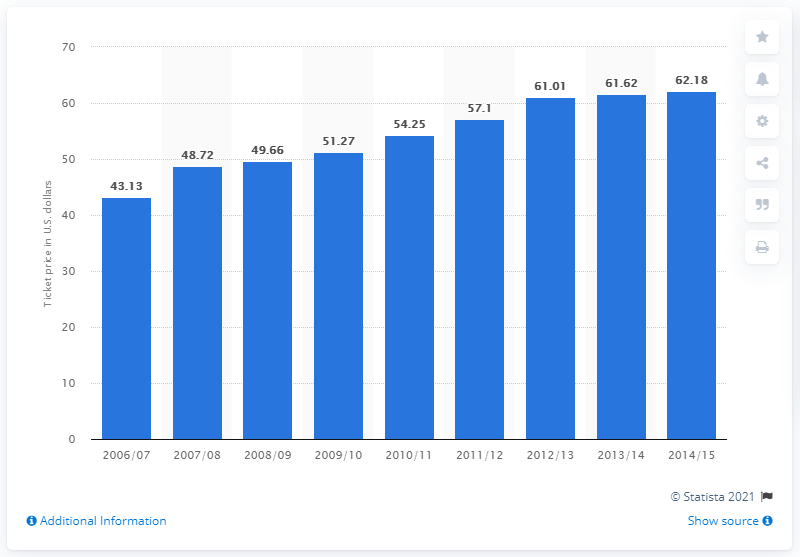Outline some significant characteristics in this image. The average ticket price in the 2006/07 season was 43.13 dollars. 